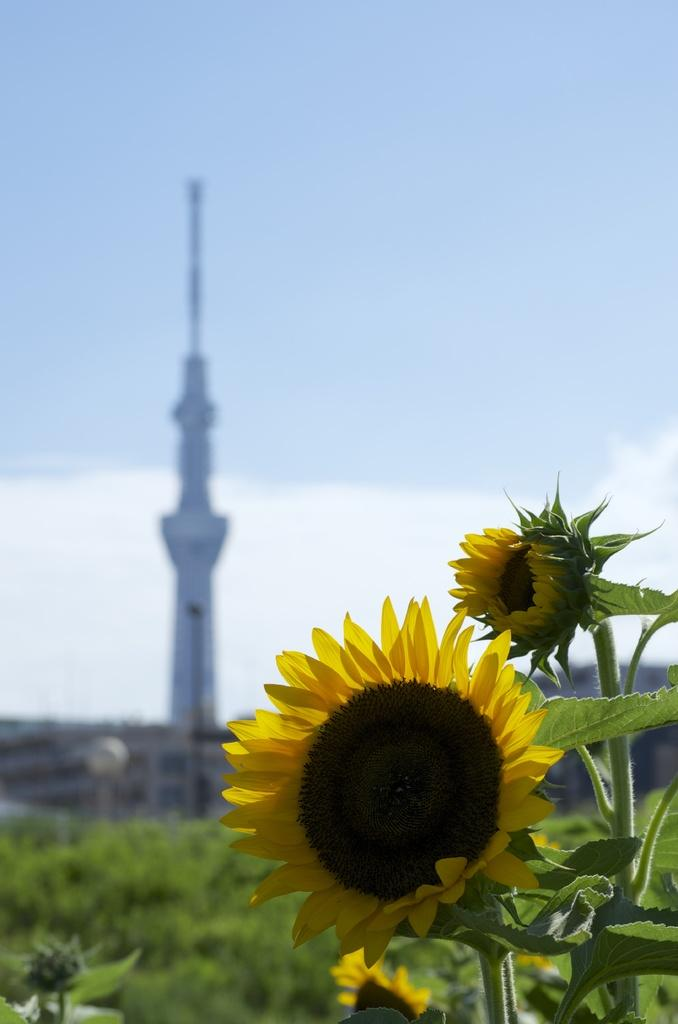What type of living organisms can be seen in the image? Plants and flowers are visible in the image. How is the background of the image depicted? The background of the image is blurred. What is the surface on which the plants and flowers are growing? There is ground visible in the image. What structure can be seen in the image? There is a tower in the image. What part of the natural environment is visible in the image? The sky is visible in the image. What type of camera is being used to take the picture of the pin in the image? There is no camera or pin present in the image; it features plants, flowers, a blurred background, ground, a tower, and the sky. 